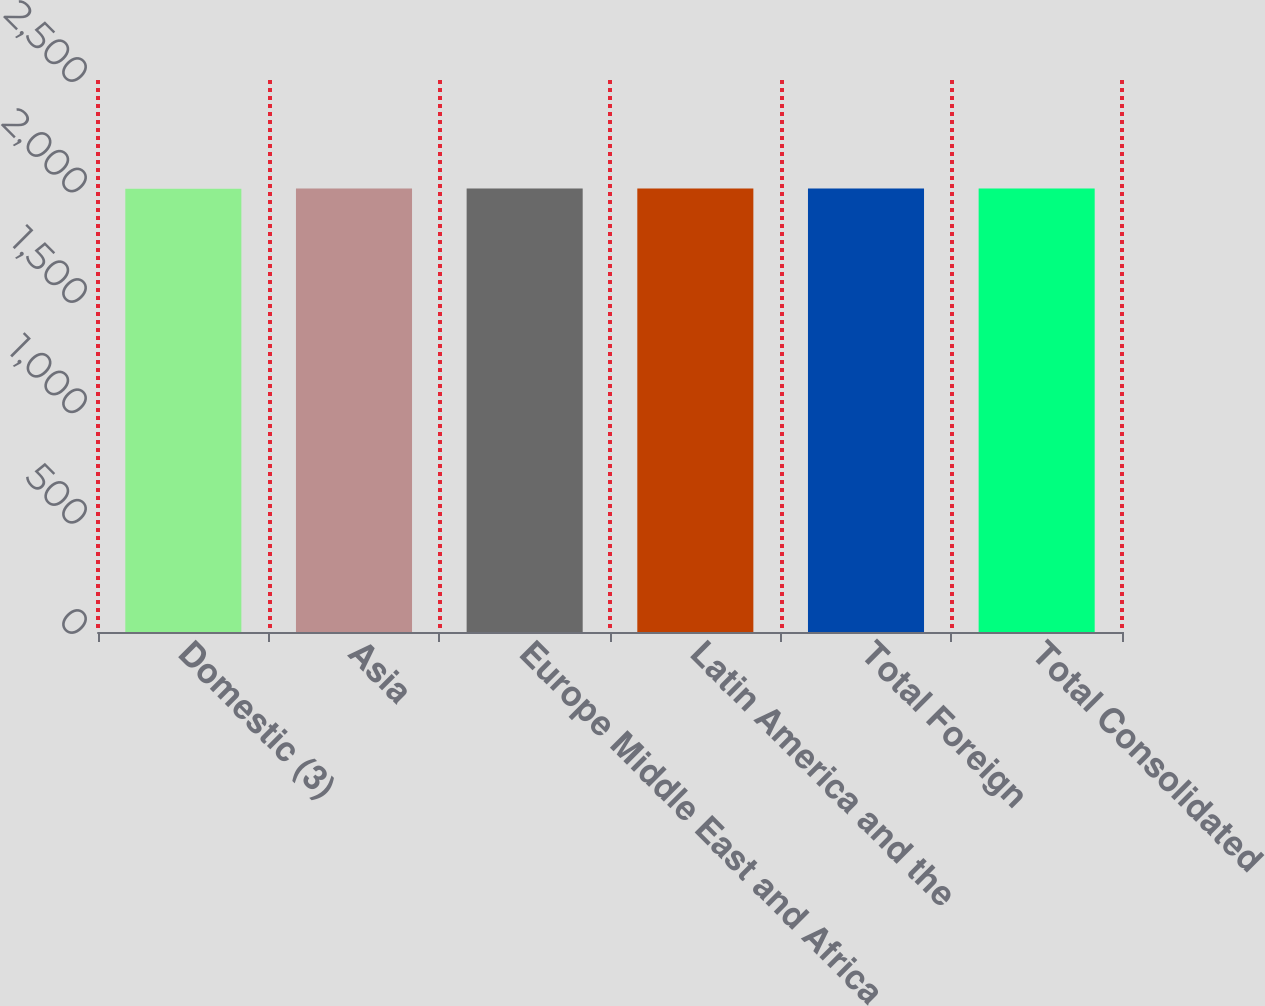Convert chart to OTSL. <chart><loc_0><loc_0><loc_500><loc_500><bar_chart><fcel>Domestic (3)<fcel>Asia<fcel>Europe Middle East and Africa<fcel>Latin America and the<fcel>Total Foreign<fcel>Total Consolidated<nl><fcel>2008<fcel>2008.1<fcel>2008.2<fcel>2008.3<fcel>2008.4<fcel>2008.5<nl></chart> 